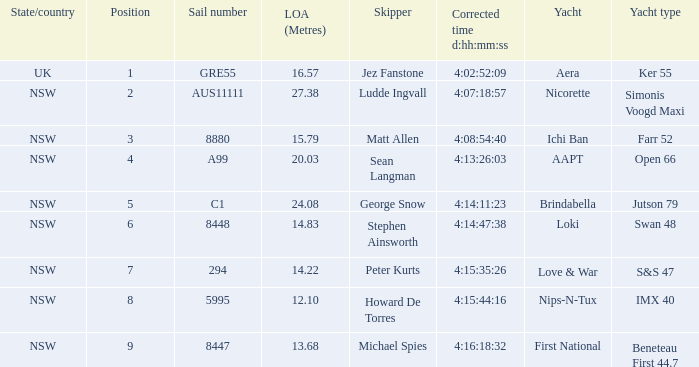What is the standing for nsw open 66 racing boat? 4.0. Can you parse all the data within this table? {'header': ['State/country', 'Position', 'Sail number', 'LOA (Metres)', 'Skipper', 'Corrected time d:hh:mm:ss', 'Yacht', 'Yacht type'], 'rows': [['UK', '1', 'GRE55', '16.57', 'Jez Fanstone', '4:02:52:09', 'Aera', 'Ker 55'], ['NSW', '2', 'AUS11111', '27.38', 'Ludde Ingvall', '4:07:18:57', 'Nicorette', 'Simonis Voogd Maxi'], ['NSW', '3', '8880', '15.79', 'Matt Allen', '4:08:54:40', 'Ichi Ban', 'Farr 52'], ['NSW', '4', 'A99', '20.03', 'Sean Langman', '4:13:26:03', 'AAPT', 'Open 66'], ['NSW', '5', 'C1', '24.08', 'George Snow', '4:14:11:23', 'Brindabella', 'Jutson 79'], ['NSW', '6', '8448', '14.83', 'Stephen Ainsworth', '4:14:47:38', 'Loki', 'Swan 48'], ['NSW', '7', '294', '14.22', 'Peter Kurts', '4:15:35:26', 'Love & War', 'S&S 47'], ['NSW', '8', '5995', '12.10', 'Howard De Torres', '4:15:44:16', 'Nips-N-Tux', 'IMX 40'], ['NSW', '9', '8447', '13.68', 'Michael Spies', '4:16:18:32', 'First National', 'Beneteau First 44.7']]} 